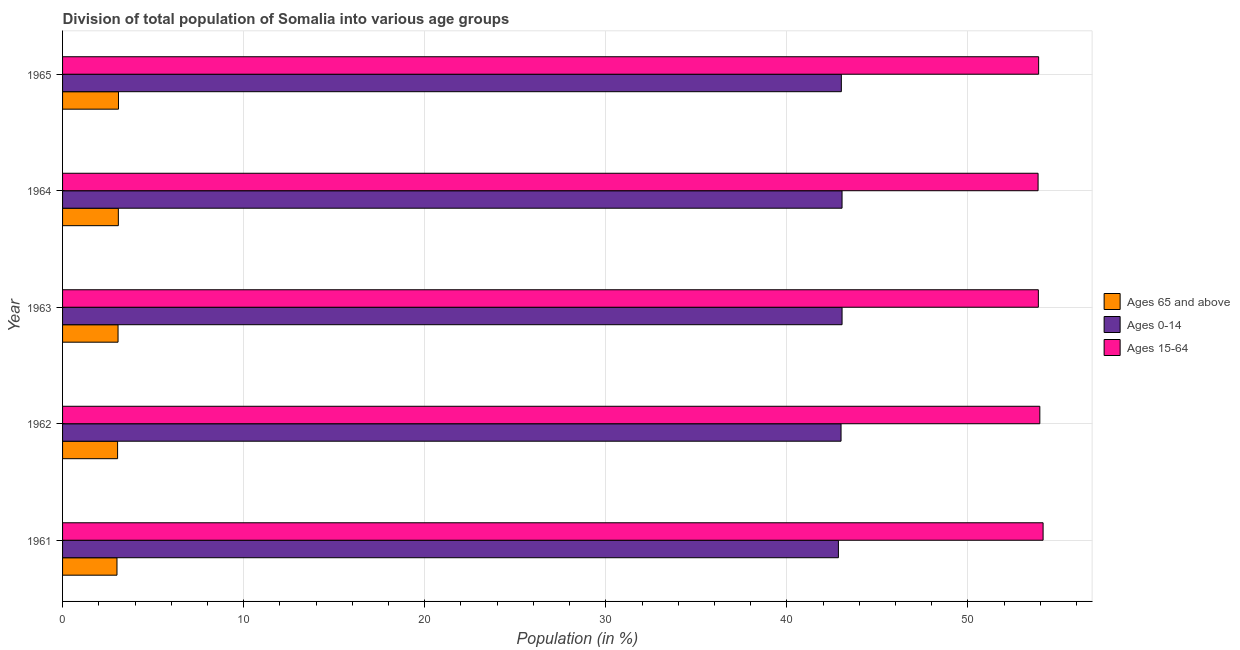How many different coloured bars are there?
Ensure brevity in your answer.  3. Are the number of bars per tick equal to the number of legend labels?
Your answer should be compact. Yes. How many bars are there on the 1st tick from the top?
Your answer should be compact. 3. How many bars are there on the 5th tick from the bottom?
Provide a short and direct response. 3. What is the label of the 4th group of bars from the top?
Keep it short and to the point. 1962. What is the percentage of population within the age-group 15-64 in 1962?
Give a very brief answer. 53.97. Across all years, what is the maximum percentage of population within the age-group of 65 and above?
Provide a succinct answer. 3.09. Across all years, what is the minimum percentage of population within the age-group 15-64?
Ensure brevity in your answer.  53.87. In which year was the percentage of population within the age-group of 65 and above maximum?
Offer a very short reply. 1965. What is the total percentage of population within the age-group 15-64 in the graph?
Your response must be concise. 269.78. What is the difference between the percentage of population within the age-group 15-64 in 1962 and that in 1965?
Your response must be concise. 0.07. What is the difference between the percentage of population within the age-group 15-64 in 1961 and the percentage of population within the age-group 0-14 in 1965?
Keep it short and to the point. 11.14. What is the average percentage of population within the age-group of 65 and above per year?
Make the answer very short. 3.06. In the year 1963, what is the difference between the percentage of population within the age-group of 65 and above and percentage of population within the age-group 0-14?
Your answer should be compact. -39.98. What is the difference between the highest and the lowest percentage of population within the age-group 15-64?
Offer a terse response. 0.28. Is the sum of the percentage of population within the age-group of 65 and above in 1962 and 1963 greater than the maximum percentage of population within the age-group 15-64 across all years?
Your response must be concise. No. What does the 2nd bar from the top in 1963 represents?
Ensure brevity in your answer.  Ages 0-14. What does the 2nd bar from the bottom in 1964 represents?
Keep it short and to the point. Ages 0-14. How many bars are there?
Provide a short and direct response. 15. How many years are there in the graph?
Keep it short and to the point. 5. What is the difference between two consecutive major ticks on the X-axis?
Offer a terse response. 10. Are the values on the major ticks of X-axis written in scientific E-notation?
Your response must be concise. No. Does the graph contain grids?
Keep it short and to the point. Yes. Where does the legend appear in the graph?
Provide a short and direct response. Center right. What is the title of the graph?
Your answer should be compact. Division of total population of Somalia into various age groups
. What is the label or title of the X-axis?
Ensure brevity in your answer.  Population (in %). What is the Population (in %) of Ages 65 and above in 1961?
Your answer should be compact. 3.01. What is the Population (in %) of Ages 0-14 in 1961?
Keep it short and to the point. 42.85. What is the Population (in %) in Ages 15-64 in 1961?
Ensure brevity in your answer.  54.15. What is the Population (in %) in Ages 65 and above in 1962?
Your answer should be very brief. 3.04. What is the Population (in %) of Ages 0-14 in 1962?
Your response must be concise. 42.99. What is the Population (in %) in Ages 15-64 in 1962?
Offer a terse response. 53.97. What is the Population (in %) of Ages 65 and above in 1963?
Your response must be concise. 3.06. What is the Population (in %) of Ages 0-14 in 1963?
Give a very brief answer. 43.05. What is the Population (in %) in Ages 15-64 in 1963?
Make the answer very short. 53.89. What is the Population (in %) of Ages 65 and above in 1964?
Your answer should be compact. 3.08. What is the Population (in %) in Ages 0-14 in 1964?
Your answer should be very brief. 43.05. What is the Population (in %) in Ages 15-64 in 1964?
Keep it short and to the point. 53.87. What is the Population (in %) of Ages 65 and above in 1965?
Your answer should be compact. 3.09. What is the Population (in %) of Ages 0-14 in 1965?
Give a very brief answer. 43.01. What is the Population (in %) in Ages 15-64 in 1965?
Provide a short and direct response. 53.9. Across all years, what is the maximum Population (in %) of Ages 65 and above?
Offer a very short reply. 3.09. Across all years, what is the maximum Population (in %) of Ages 0-14?
Your answer should be very brief. 43.05. Across all years, what is the maximum Population (in %) of Ages 15-64?
Give a very brief answer. 54.15. Across all years, what is the minimum Population (in %) in Ages 65 and above?
Your response must be concise. 3.01. Across all years, what is the minimum Population (in %) of Ages 0-14?
Your answer should be very brief. 42.85. Across all years, what is the minimum Population (in %) in Ages 15-64?
Provide a short and direct response. 53.87. What is the total Population (in %) in Ages 65 and above in the graph?
Make the answer very short. 15.28. What is the total Population (in %) of Ages 0-14 in the graph?
Your answer should be compact. 214.94. What is the total Population (in %) in Ages 15-64 in the graph?
Keep it short and to the point. 269.78. What is the difference between the Population (in %) in Ages 65 and above in 1961 and that in 1962?
Give a very brief answer. -0.03. What is the difference between the Population (in %) in Ages 0-14 in 1961 and that in 1962?
Give a very brief answer. -0.15. What is the difference between the Population (in %) in Ages 15-64 in 1961 and that in 1962?
Make the answer very short. 0.18. What is the difference between the Population (in %) in Ages 65 and above in 1961 and that in 1963?
Provide a succinct answer. -0.06. What is the difference between the Population (in %) in Ages 0-14 in 1961 and that in 1963?
Your answer should be very brief. -0.2. What is the difference between the Population (in %) in Ages 15-64 in 1961 and that in 1963?
Your response must be concise. 0.26. What is the difference between the Population (in %) of Ages 65 and above in 1961 and that in 1964?
Your answer should be compact. -0.08. What is the difference between the Population (in %) of Ages 0-14 in 1961 and that in 1964?
Ensure brevity in your answer.  -0.2. What is the difference between the Population (in %) in Ages 15-64 in 1961 and that in 1964?
Your response must be concise. 0.28. What is the difference between the Population (in %) in Ages 65 and above in 1961 and that in 1965?
Give a very brief answer. -0.08. What is the difference between the Population (in %) of Ages 0-14 in 1961 and that in 1965?
Ensure brevity in your answer.  -0.16. What is the difference between the Population (in %) in Ages 15-64 in 1961 and that in 1965?
Offer a very short reply. 0.25. What is the difference between the Population (in %) of Ages 65 and above in 1962 and that in 1963?
Your answer should be compact. -0.02. What is the difference between the Population (in %) in Ages 0-14 in 1962 and that in 1963?
Ensure brevity in your answer.  -0.06. What is the difference between the Population (in %) in Ages 15-64 in 1962 and that in 1963?
Your answer should be compact. 0.08. What is the difference between the Population (in %) of Ages 65 and above in 1962 and that in 1964?
Provide a short and direct response. -0.04. What is the difference between the Population (in %) of Ages 0-14 in 1962 and that in 1964?
Your answer should be very brief. -0.06. What is the difference between the Population (in %) of Ages 15-64 in 1962 and that in 1964?
Offer a terse response. 0.1. What is the difference between the Population (in %) of Ages 65 and above in 1962 and that in 1965?
Offer a very short reply. -0.05. What is the difference between the Population (in %) in Ages 0-14 in 1962 and that in 1965?
Provide a short and direct response. -0.02. What is the difference between the Population (in %) in Ages 15-64 in 1962 and that in 1965?
Keep it short and to the point. 0.07. What is the difference between the Population (in %) of Ages 65 and above in 1963 and that in 1964?
Provide a short and direct response. -0.02. What is the difference between the Population (in %) in Ages 0-14 in 1963 and that in 1964?
Provide a short and direct response. 0. What is the difference between the Population (in %) of Ages 15-64 in 1963 and that in 1964?
Provide a short and direct response. 0.01. What is the difference between the Population (in %) in Ages 65 and above in 1963 and that in 1965?
Make the answer very short. -0.02. What is the difference between the Population (in %) in Ages 0-14 in 1963 and that in 1965?
Provide a short and direct response. 0.04. What is the difference between the Population (in %) of Ages 15-64 in 1963 and that in 1965?
Offer a very short reply. -0.02. What is the difference between the Population (in %) of Ages 65 and above in 1964 and that in 1965?
Ensure brevity in your answer.  -0.01. What is the difference between the Population (in %) of Ages 0-14 in 1964 and that in 1965?
Your answer should be very brief. 0.04. What is the difference between the Population (in %) of Ages 15-64 in 1964 and that in 1965?
Keep it short and to the point. -0.03. What is the difference between the Population (in %) in Ages 65 and above in 1961 and the Population (in %) in Ages 0-14 in 1962?
Provide a short and direct response. -39.99. What is the difference between the Population (in %) in Ages 65 and above in 1961 and the Population (in %) in Ages 15-64 in 1962?
Provide a short and direct response. -50.96. What is the difference between the Population (in %) in Ages 0-14 in 1961 and the Population (in %) in Ages 15-64 in 1962?
Give a very brief answer. -11.12. What is the difference between the Population (in %) of Ages 65 and above in 1961 and the Population (in %) of Ages 0-14 in 1963?
Provide a succinct answer. -40.04. What is the difference between the Population (in %) in Ages 65 and above in 1961 and the Population (in %) in Ages 15-64 in 1963?
Make the answer very short. -50.88. What is the difference between the Population (in %) in Ages 0-14 in 1961 and the Population (in %) in Ages 15-64 in 1963?
Keep it short and to the point. -11.04. What is the difference between the Population (in %) of Ages 65 and above in 1961 and the Population (in %) of Ages 0-14 in 1964?
Your answer should be compact. -40.04. What is the difference between the Population (in %) in Ages 65 and above in 1961 and the Population (in %) in Ages 15-64 in 1964?
Provide a succinct answer. -50.87. What is the difference between the Population (in %) of Ages 0-14 in 1961 and the Population (in %) of Ages 15-64 in 1964?
Your answer should be very brief. -11.03. What is the difference between the Population (in %) in Ages 65 and above in 1961 and the Population (in %) in Ages 0-14 in 1965?
Keep it short and to the point. -40. What is the difference between the Population (in %) of Ages 65 and above in 1961 and the Population (in %) of Ages 15-64 in 1965?
Provide a succinct answer. -50.9. What is the difference between the Population (in %) of Ages 0-14 in 1961 and the Population (in %) of Ages 15-64 in 1965?
Give a very brief answer. -11.06. What is the difference between the Population (in %) in Ages 65 and above in 1962 and the Population (in %) in Ages 0-14 in 1963?
Provide a succinct answer. -40.01. What is the difference between the Population (in %) of Ages 65 and above in 1962 and the Population (in %) of Ages 15-64 in 1963?
Offer a very short reply. -50.85. What is the difference between the Population (in %) in Ages 0-14 in 1962 and the Population (in %) in Ages 15-64 in 1963?
Offer a terse response. -10.9. What is the difference between the Population (in %) of Ages 65 and above in 1962 and the Population (in %) of Ages 0-14 in 1964?
Provide a succinct answer. -40.01. What is the difference between the Population (in %) of Ages 65 and above in 1962 and the Population (in %) of Ages 15-64 in 1964?
Offer a very short reply. -50.83. What is the difference between the Population (in %) of Ages 0-14 in 1962 and the Population (in %) of Ages 15-64 in 1964?
Provide a short and direct response. -10.88. What is the difference between the Population (in %) of Ages 65 and above in 1962 and the Population (in %) of Ages 0-14 in 1965?
Keep it short and to the point. -39.97. What is the difference between the Population (in %) of Ages 65 and above in 1962 and the Population (in %) of Ages 15-64 in 1965?
Ensure brevity in your answer.  -50.86. What is the difference between the Population (in %) in Ages 0-14 in 1962 and the Population (in %) in Ages 15-64 in 1965?
Offer a very short reply. -10.91. What is the difference between the Population (in %) of Ages 65 and above in 1963 and the Population (in %) of Ages 0-14 in 1964?
Provide a succinct answer. -39.98. What is the difference between the Population (in %) in Ages 65 and above in 1963 and the Population (in %) in Ages 15-64 in 1964?
Offer a very short reply. -50.81. What is the difference between the Population (in %) in Ages 0-14 in 1963 and the Population (in %) in Ages 15-64 in 1964?
Keep it short and to the point. -10.82. What is the difference between the Population (in %) of Ages 65 and above in 1963 and the Population (in %) of Ages 0-14 in 1965?
Ensure brevity in your answer.  -39.94. What is the difference between the Population (in %) in Ages 65 and above in 1963 and the Population (in %) in Ages 15-64 in 1965?
Ensure brevity in your answer.  -50.84. What is the difference between the Population (in %) in Ages 0-14 in 1963 and the Population (in %) in Ages 15-64 in 1965?
Make the answer very short. -10.86. What is the difference between the Population (in %) of Ages 65 and above in 1964 and the Population (in %) of Ages 0-14 in 1965?
Your answer should be compact. -39.93. What is the difference between the Population (in %) in Ages 65 and above in 1964 and the Population (in %) in Ages 15-64 in 1965?
Give a very brief answer. -50.82. What is the difference between the Population (in %) of Ages 0-14 in 1964 and the Population (in %) of Ages 15-64 in 1965?
Your response must be concise. -10.86. What is the average Population (in %) of Ages 65 and above per year?
Your answer should be compact. 3.06. What is the average Population (in %) of Ages 0-14 per year?
Offer a very short reply. 42.99. What is the average Population (in %) in Ages 15-64 per year?
Keep it short and to the point. 53.96. In the year 1961, what is the difference between the Population (in %) in Ages 65 and above and Population (in %) in Ages 0-14?
Your response must be concise. -39.84. In the year 1961, what is the difference between the Population (in %) in Ages 65 and above and Population (in %) in Ages 15-64?
Offer a very short reply. -51.14. In the year 1961, what is the difference between the Population (in %) in Ages 0-14 and Population (in %) in Ages 15-64?
Offer a terse response. -11.3. In the year 1962, what is the difference between the Population (in %) in Ages 65 and above and Population (in %) in Ages 0-14?
Offer a very short reply. -39.95. In the year 1962, what is the difference between the Population (in %) of Ages 65 and above and Population (in %) of Ages 15-64?
Keep it short and to the point. -50.93. In the year 1962, what is the difference between the Population (in %) of Ages 0-14 and Population (in %) of Ages 15-64?
Your answer should be compact. -10.98. In the year 1963, what is the difference between the Population (in %) in Ages 65 and above and Population (in %) in Ages 0-14?
Ensure brevity in your answer.  -39.98. In the year 1963, what is the difference between the Population (in %) in Ages 65 and above and Population (in %) in Ages 15-64?
Keep it short and to the point. -50.82. In the year 1963, what is the difference between the Population (in %) in Ages 0-14 and Population (in %) in Ages 15-64?
Your answer should be compact. -10.84. In the year 1964, what is the difference between the Population (in %) of Ages 65 and above and Population (in %) of Ages 0-14?
Keep it short and to the point. -39.97. In the year 1964, what is the difference between the Population (in %) in Ages 65 and above and Population (in %) in Ages 15-64?
Offer a terse response. -50.79. In the year 1964, what is the difference between the Population (in %) in Ages 0-14 and Population (in %) in Ages 15-64?
Offer a very short reply. -10.83. In the year 1965, what is the difference between the Population (in %) of Ages 65 and above and Population (in %) of Ages 0-14?
Offer a terse response. -39.92. In the year 1965, what is the difference between the Population (in %) of Ages 65 and above and Population (in %) of Ages 15-64?
Provide a succinct answer. -50.82. In the year 1965, what is the difference between the Population (in %) of Ages 0-14 and Population (in %) of Ages 15-64?
Your response must be concise. -10.9. What is the ratio of the Population (in %) in Ages 0-14 in 1961 to that in 1962?
Your answer should be compact. 1. What is the ratio of the Population (in %) of Ages 15-64 in 1961 to that in 1962?
Your response must be concise. 1. What is the ratio of the Population (in %) in Ages 65 and above in 1961 to that in 1963?
Provide a short and direct response. 0.98. What is the ratio of the Population (in %) of Ages 65 and above in 1961 to that in 1964?
Keep it short and to the point. 0.98. What is the ratio of the Population (in %) in Ages 0-14 in 1961 to that in 1964?
Offer a terse response. 1. What is the ratio of the Population (in %) of Ages 15-64 in 1961 to that in 1964?
Your answer should be very brief. 1.01. What is the ratio of the Population (in %) in Ages 65 and above in 1961 to that in 1965?
Keep it short and to the point. 0.97. What is the ratio of the Population (in %) in Ages 0-14 in 1961 to that in 1965?
Offer a terse response. 1. What is the ratio of the Population (in %) of Ages 15-64 in 1961 to that in 1965?
Ensure brevity in your answer.  1. What is the ratio of the Population (in %) of Ages 0-14 in 1962 to that in 1963?
Your answer should be compact. 1. What is the ratio of the Population (in %) of Ages 15-64 in 1962 to that in 1963?
Offer a terse response. 1. What is the ratio of the Population (in %) of Ages 65 and above in 1962 to that in 1964?
Ensure brevity in your answer.  0.99. What is the ratio of the Population (in %) of Ages 0-14 in 1962 to that in 1964?
Ensure brevity in your answer.  1. What is the ratio of the Population (in %) in Ages 15-64 in 1962 to that in 1964?
Give a very brief answer. 1. What is the ratio of the Population (in %) of Ages 65 and above in 1962 to that in 1965?
Offer a very short reply. 0.98. What is the ratio of the Population (in %) of Ages 0-14 in 1962 to that in 1965?
Make the answer very short. 1. What is the ratio of the Population (in %) of Ages 15-64 in 1962 to that in 1965?
Give a very brief answer. 1. What is the ratio of the Population (in %) of Ages 65 and above in 1963 to that in 1964?
Your answer should be compact. 0.99. What is the ratio of the Population (in %) in Ages 0-14 in 1963 to that in 1964?
Your answer should be compact. 1. What is the ratio of the Population (in %) of Ages 15-64 in 1963 to that in 1964?
Provide a succinct answer. 1. What is the ratio of the Population (in %) in Ages 15-64 in 1963 to that in 1965?
Your response must be concise. 1. What is the ratio of the Population (in %) of Ages 15-64 in 1964 to that in 1965?
Ensure brevity in your answer.  1. What is the difference between the highest and the second highest Population (in %) in Ages 65 and above?
Your answer should be very brief. 0.01. What is the difference between the highest and the second highest Population (in %) in Ages 0-14?
Your answer should be compact. 0. What is the difference between the highest and the second highest Population (in %) of Ages 15-64?
Offer a very short reply. 0.18. What is the difference between the highest and the lowest Population (in %) of Ages 65 and above?
Give a very brief answer. 0.08. What is the difference between the highest and the lowest Population (in %) in Ages 0-14?
Your answer should be very brief. 0.2. What is the difference between the highest and the lowest Population (in %) of Ages 15-64?
Provide a succinct answer. 0.28. 